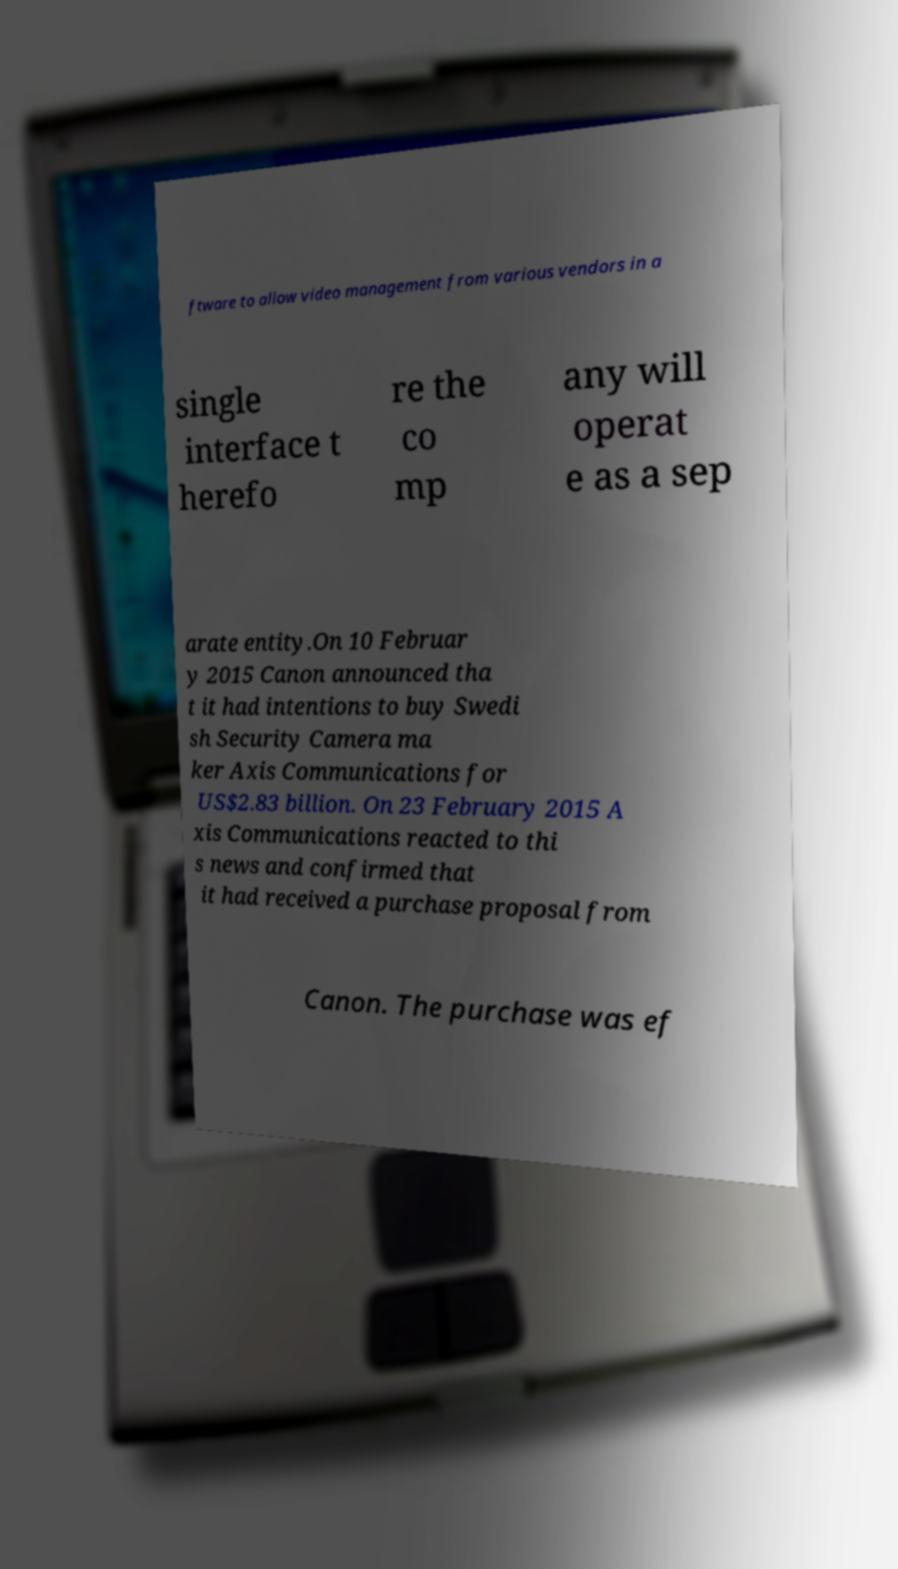What messages or text are displayed in this image? I need them in a readable, typed format. ftware to allow video management from various vendors in a single interface t herefo re the co mp any will operat e as a sep arate entity.On 10 Februar y 2015 Canon announced tha t it had intentions to buy Swedi sh Security Camera ma ker Axis Communications for US$2.83 billion. On 23 February 2015 A xis Communications reacted to thi s news and confirmed that it had received a purchase proposal from Canon. The purchase was ef 